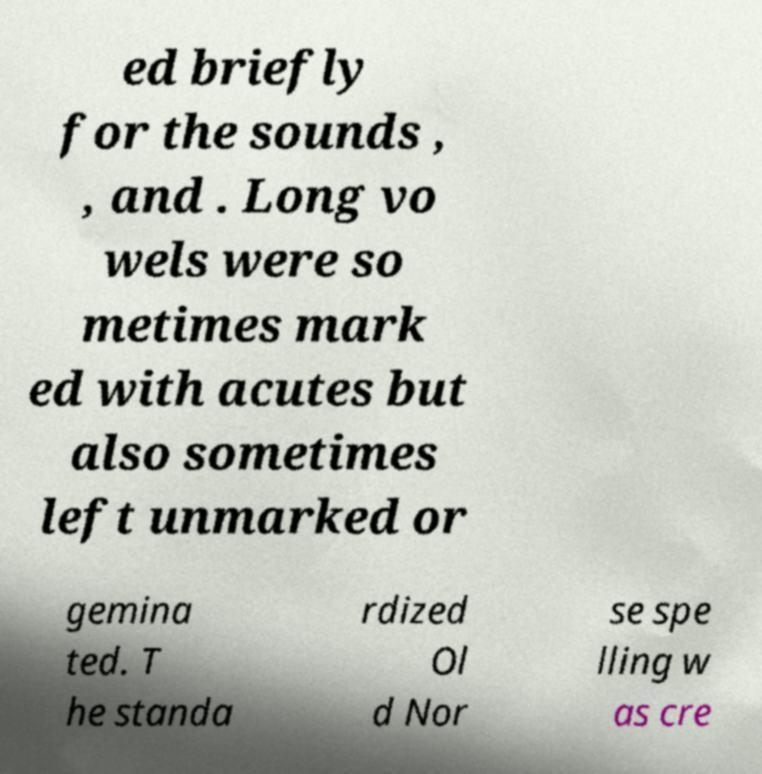I need the written content from this picture converted into text. Can you do that? ed briefly for the sounds , , and . Long vo wels were so metimes mark ed with acutes but also sometimes left unmarked or gemina ted. T he standa rdized Ol d Nor se spe lling w as cre 